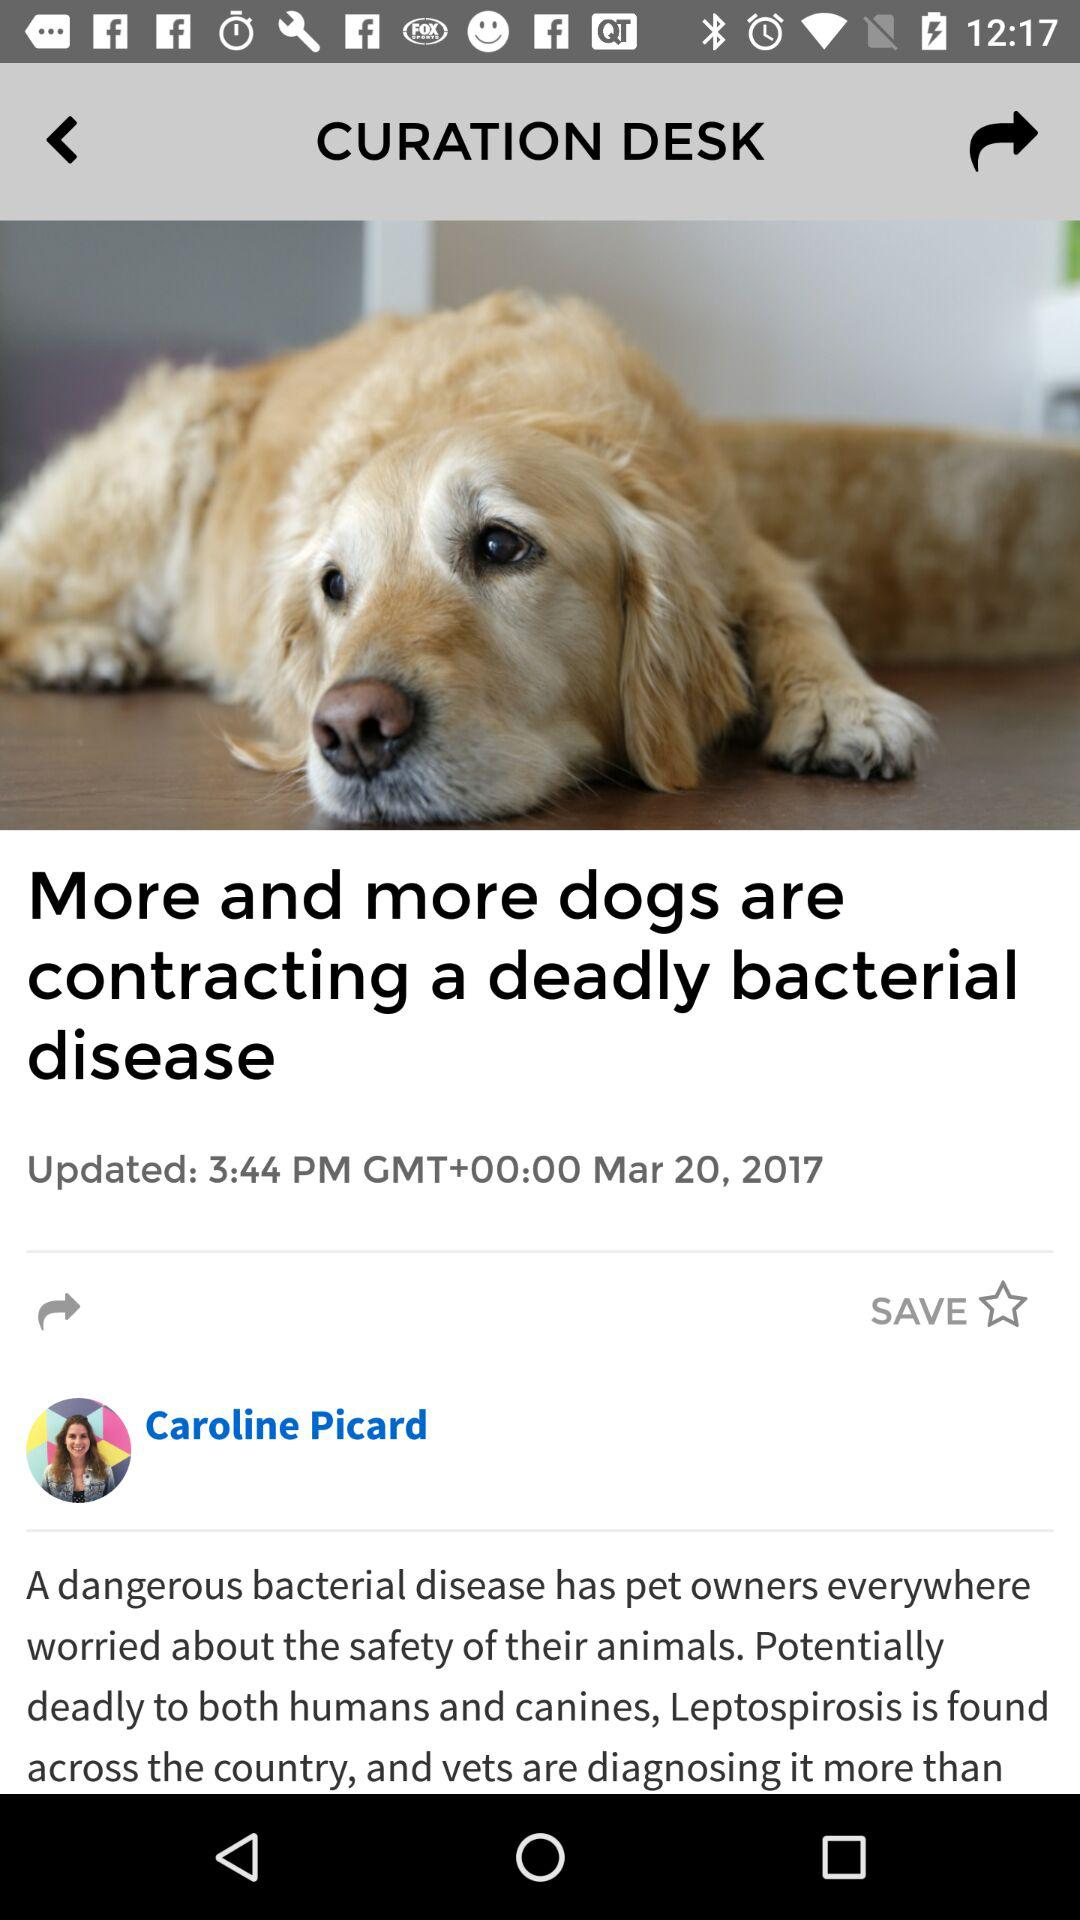When was Caroline Picard's article originally posted?
When the provided information is insufficient, respond with <no answer>. <no answer> 